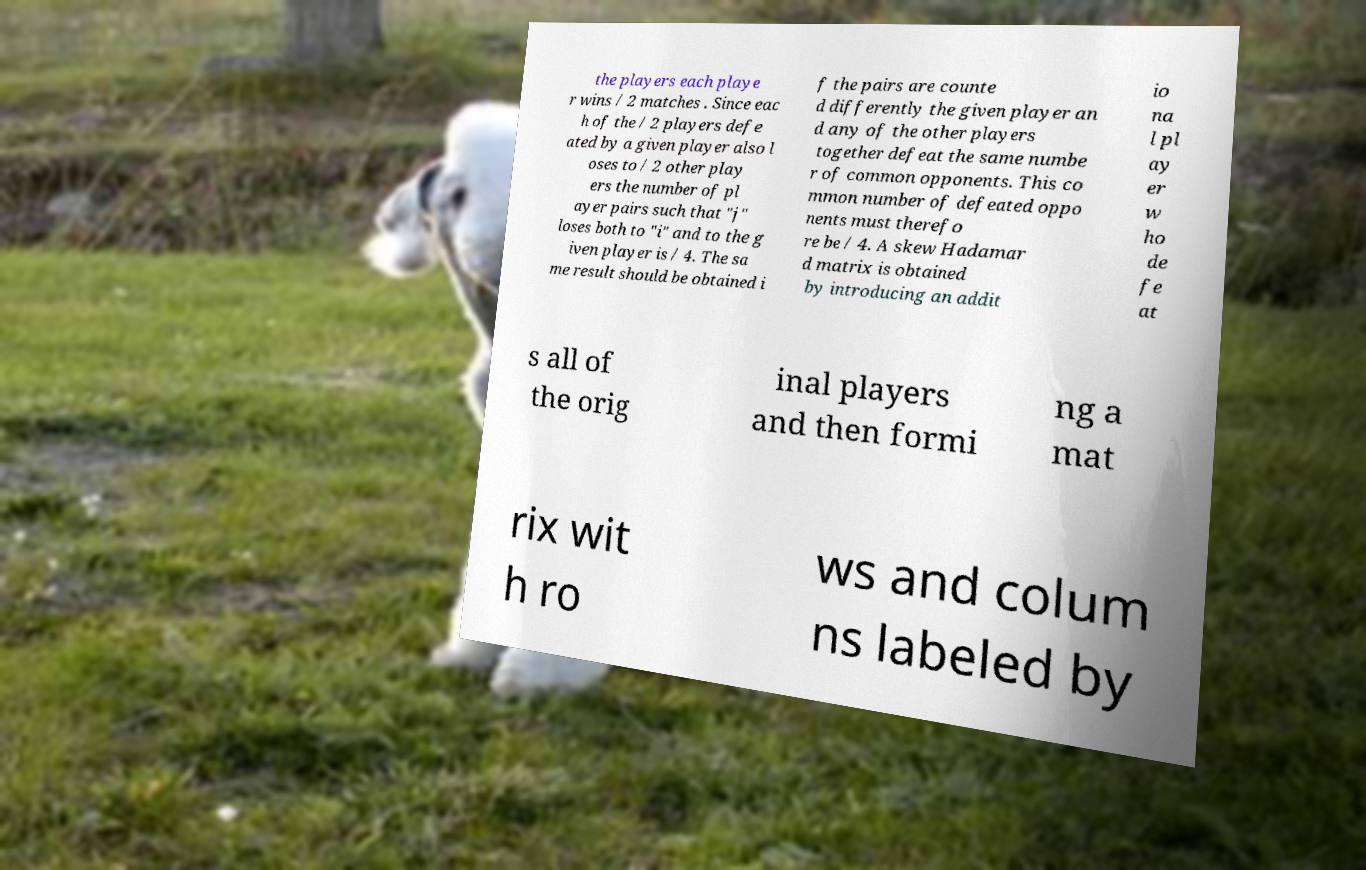Could you assist in decoding the text presented in this image and type it out clearly? the players each playe r wins / 2 matches . Since eac h of the / 2 players defe ated by a given player also l oses to / 2 other play ers the number of pl ayer pairs such that "j" loses both to "i" and to the g iven player is / 4. The sa me result should be obtained i f the pairs are counte d differently the given player an d any of the other players together defeat the same numbe r of common opponents. This co mmon number of defeated oppo nents must therefo re be / 4. A skew Hadamar d matrix is obtained by introducing an addit io na l pl ay er w ho de fe at s all of the orig inal players and then formi ng a mat rix wit h ro ws and colum ns labeled by 